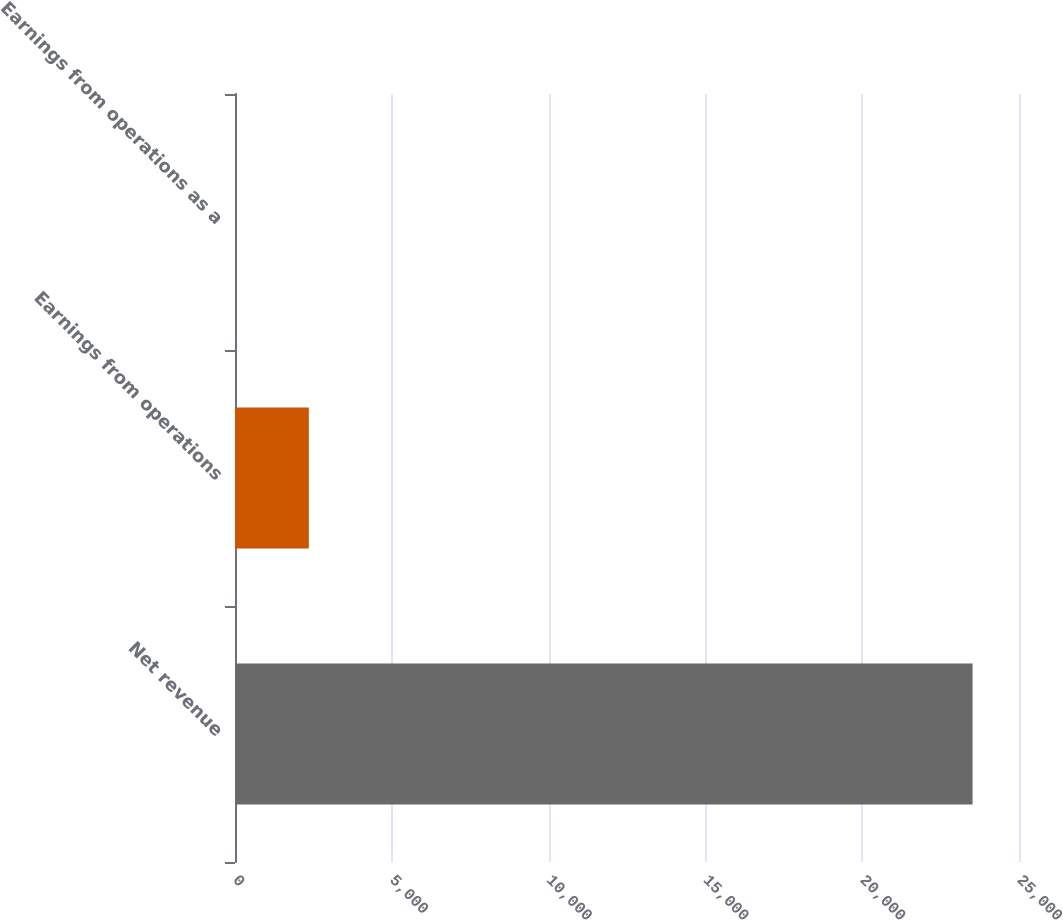Convert chart to OTSL. <chart><loc_0><loc_0><loc_500><loc_500><bar_chart><fcel>Net revenue<fcel>Earnings from operations<fcel>Earnings from operations as a<nl><fcel>23520<fcel>2354.61<fcel>2.9<nl></chart> 